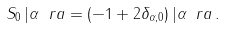<formula> <loc_0><loc_0><loc_500><loc_500>S _ { 0 } \, | \alpha \ r a = ( - 1 + 2 \delta _ { \alpha , 0 } ) \, | \alpha \ r a \, .</formula> 